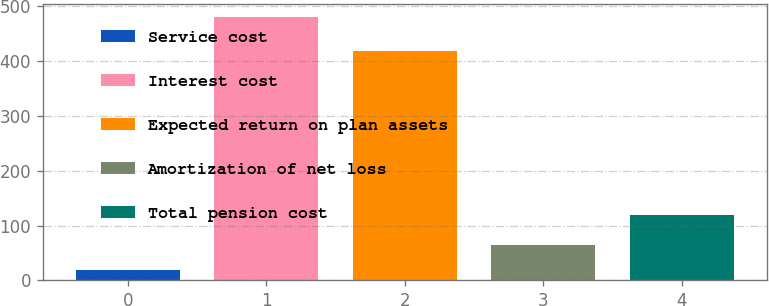Convert chart to OTSL. <chart><loc_0><loc_0><loc_500><loc_500><bar_chart><fcel>Service cost<fcel>Interest cost<fcel>Expected return on plan assets<fcel>Amortization of net loss<fcel>Total pension cost<nl><fcel>19<fcel>481<fcel>418<fcel>65.2<fcel>120<nl></chart> 